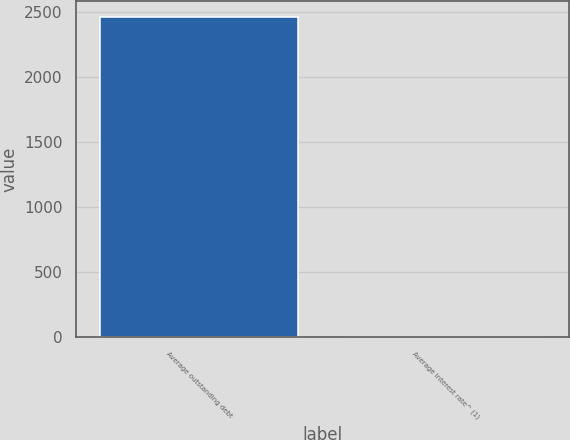Convert chart. <chart><loc_0><loc_0><loc_500><loc_500><bar_chart><fcel>Average outstanding debt<fcel>Average interest rate^ (1)<nl><fcel>2461<fcel>4.8<nl></chart> 